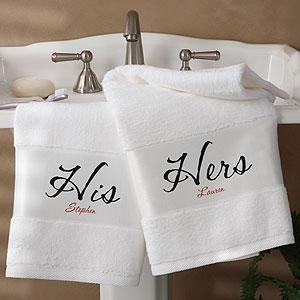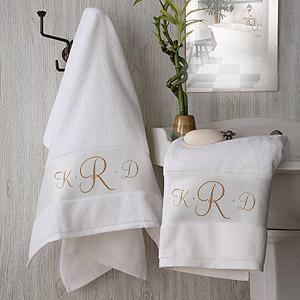The first image is the image on the left, the second image is the image on the right. For the images displayed, is the sentence "Each image shows lettered towels draped near a faucet." factually correct? Answer yes or no. Yes. 